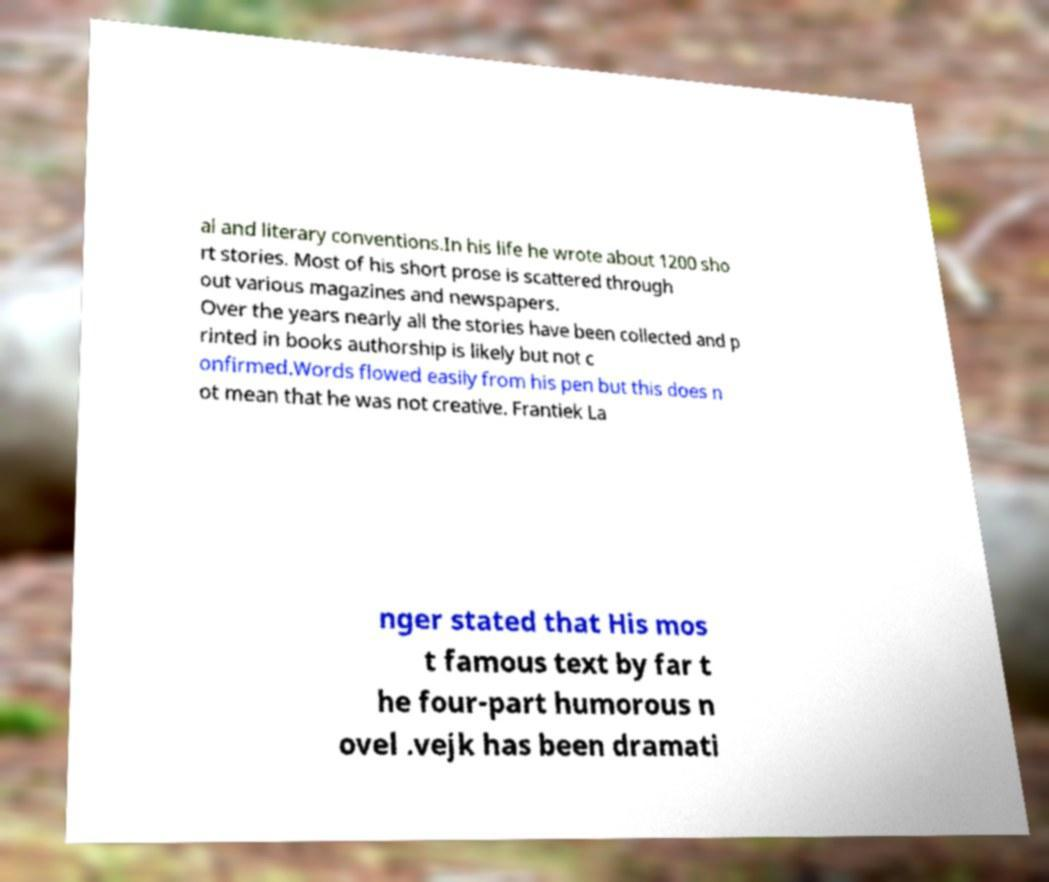Could you assist in decoding the text presented in this image and type it out clearly? al and literary conventions.In his life he wrote about 1200 sho rt stories. Most of his short prose is scattered through out various magazines and newspapers. Over the years nearly all the stories have been collected and p rinted in books authorship is likely but not c onfirmed.Words flowed easily from his pen but this does n ot mean that he was not creative. Frantiek La nger stated that His mos t famous text by far t he four-part humorous n ovel .vejk has been dramati 